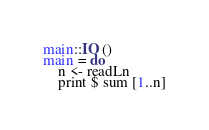<code> <loc_0><loc_0><loc_500><loc_500><_Haskell_>main::IO ()
main = do
    n <- readLn
    print $ sum [1..n]</code> 